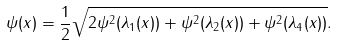<formula> <loc_0><loc_0><loc_500><loc_500>\| \psi ( x ) \| = \frac { 1 } { 2 } \sqrt { 2 \psi ^ { 2 } ( \lambda _ { 1 } ( x ) ) + \psi ^ { 2 } ( \lambda _ { 2 } ( x ) ) + \psi ^ { 2 } ( \lambda _ { 4 } ( x ) ) } .</formula> 